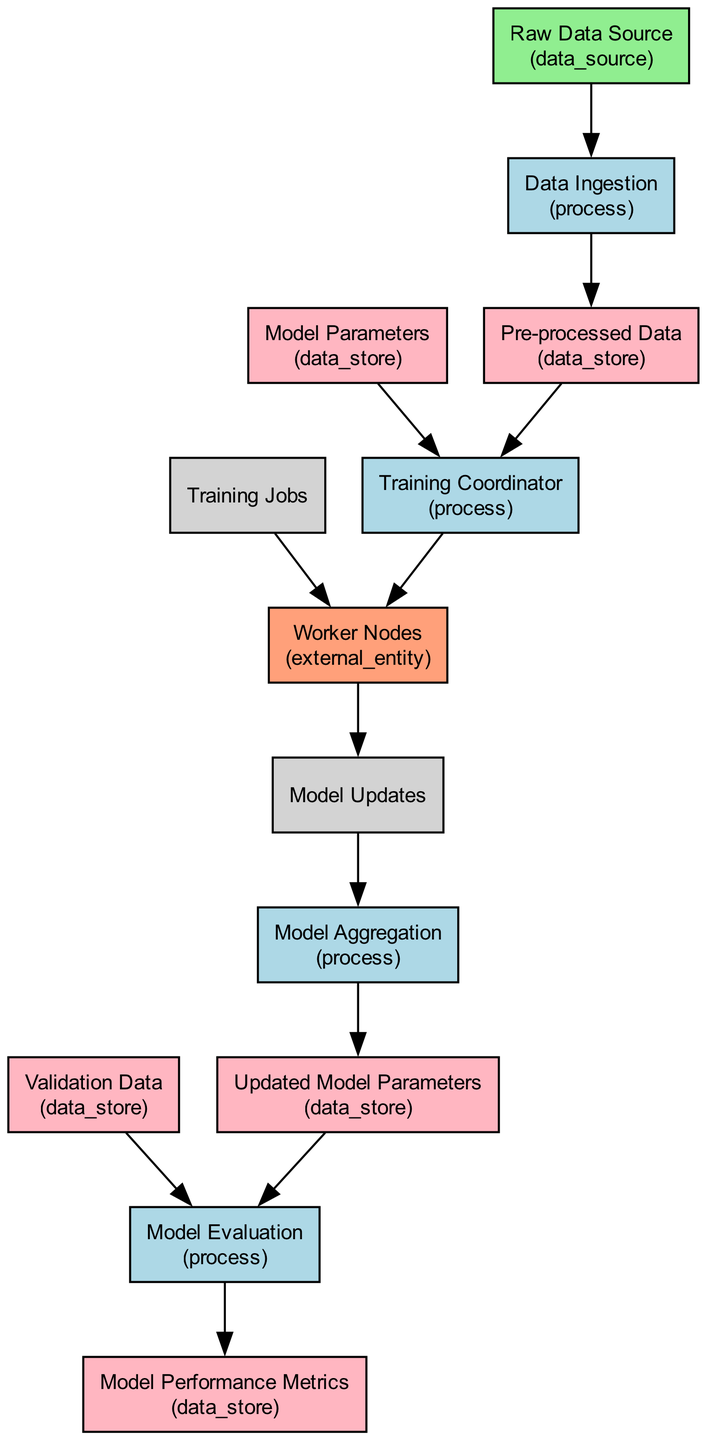What is the initial data source in this workflow? The initial data source is indicated as "Raw Data Source" in the diagram which supplies the raw data needed for processing.
Answer: Raw Data Source How many processes are depicted in the diagram? The diagram shows a total of five processes: Data Ingestion, Training Coordinator, Model Aggregation, Model Evaluation, and a final output that is implied.
Answer: Five What data store holds the pre-processed data? The pre-processed data is stored in a node labeled "Pre-processed Data," indicating that this data is clean and ready for training.
Answer: Pre-processed Data Who receives the training jobs in this workflow? The "Worker Nodes" are the entities responsible for receiving the distributed training jobs as shown in the edge connection from the Training Coordinator.
Answer: Worker Nodes What is the output of the Model Aggregation process? The output of the Model Aggregation process is "Updated Model Parameters," which are the result of combining model updates from the worker nodes.
Answer: Updated Model Parameters What is the relationship between Pre-processed Data and Training Coordinator? The "Training Coordinator" process receives the Pre-processed Data as input, meaning this data is necessary for coordinating the training jobs.
Answer: Input relationship How is model performance evaluated in this workflow? The model performance is evaluated by the "Model Evaluation" process, which uses updated model parameters and validation data to assess performance metrics.
Answer: Model Evaluation What type of nodes are Worker Nodes classified as? The Worker Nodes are classified as "external_entity" in the diagram, representing systems or entities outside the main workflow that perform computations.
Answer: External entity Which data flow links the Worker Nodes and the Model Aggregation process? The data flow labeled "Model Updates" connects the Worker Nodes back to the Model Aggregation process, indicating the feedback of updated parameters.
Answer: Model Updates 